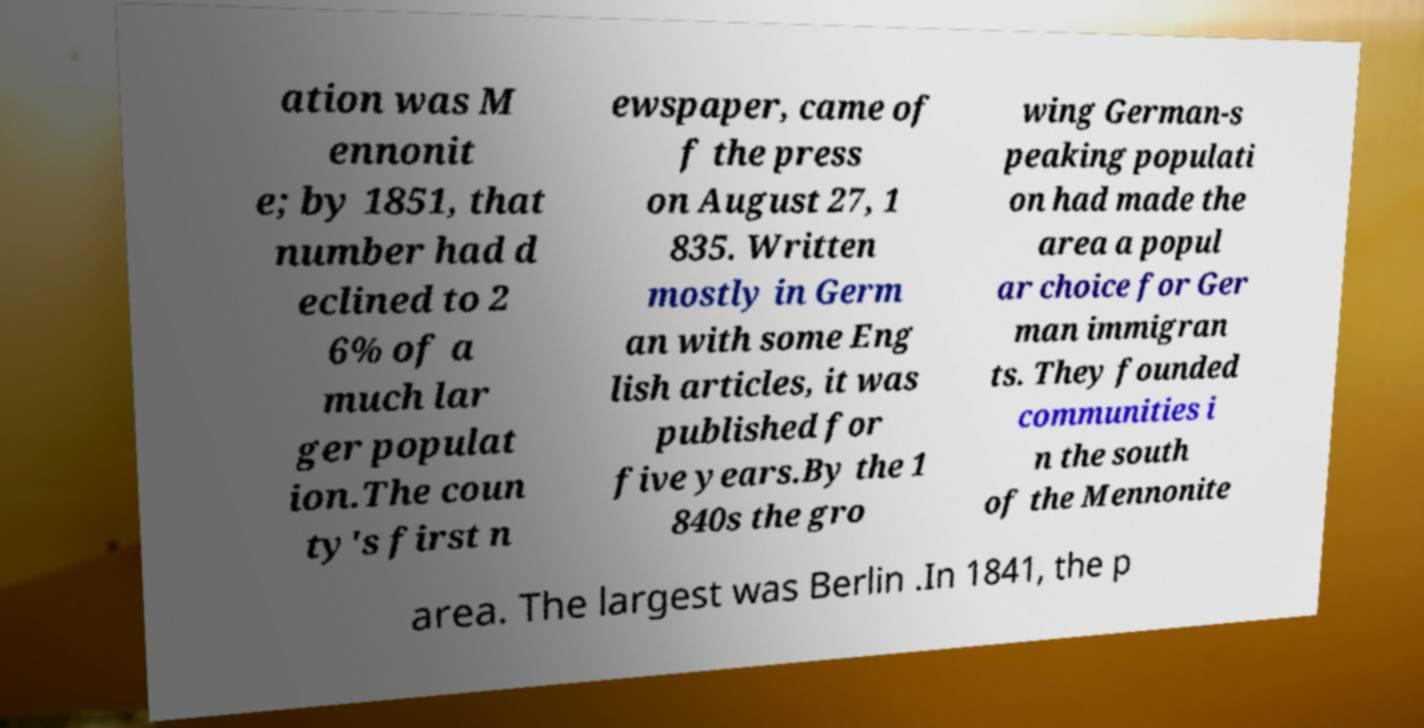There's text embedded in this image that I need extracted. Can you transcribe it verbatim? ation was M ennonit e; by 1851, that number had d eclined to 2 6% of a much lar ger populat ion.The coun ty's first n ewspaper, came of f the press on August 27, 1 835. Written mostly in Germ an with some Eng lish articles, it was published for five years.By the 1 840s the gro wing German-s peaking populati on had made the area a popul ar choice for Ger man immigran ts. They founded communities i n the south of the Mennonite area. The largest was Berlin .In 1841, the p 